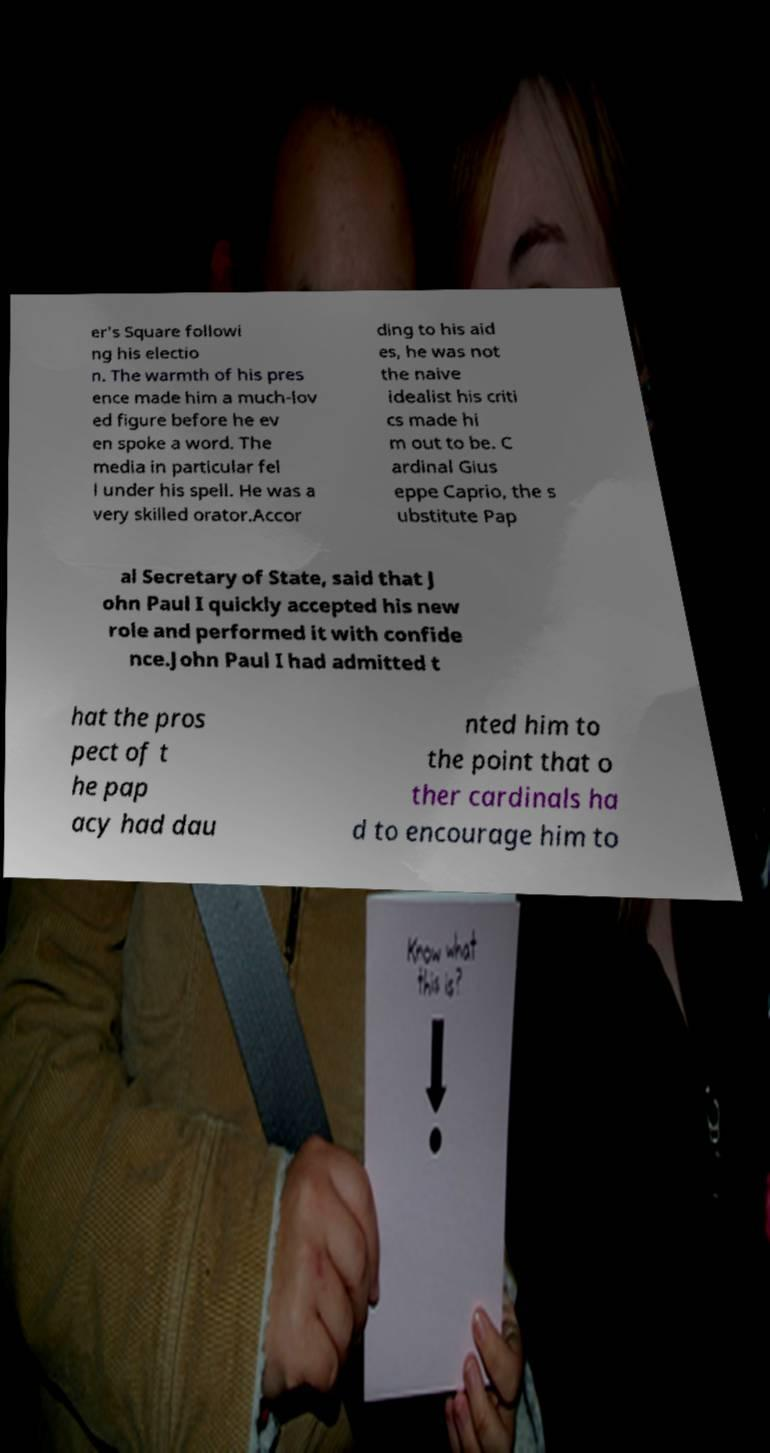Can you accurately transcribe the text from the provided image for me? er's Square followi ng his electio n. The warmth of his pres ence made him a much-lov ed figure before he ev en spoke a word. The media in particular fel l under his spell. He was a very skilled orator.Accor ding to his aid es, he was not the naive idealist his criti cs made hi m out to be. C ardinal Gius eppe Caprio, the s ubstitute Pap al Secretary of State, said that J ohn Paul I quickly accepted his new role and performed it with confide nce.John Paul I had admitted t hat the pros pect of t he pap acy had dau nted him to the point that o ther cardinals ha d to encourage him to 